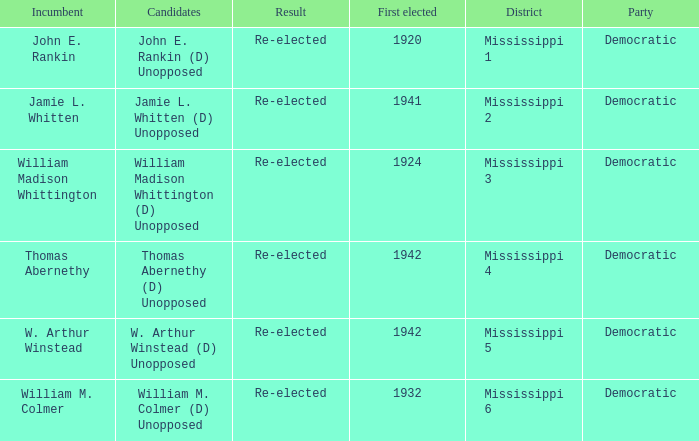What is the incumbent from 1941? Jamie L. Whitten. 